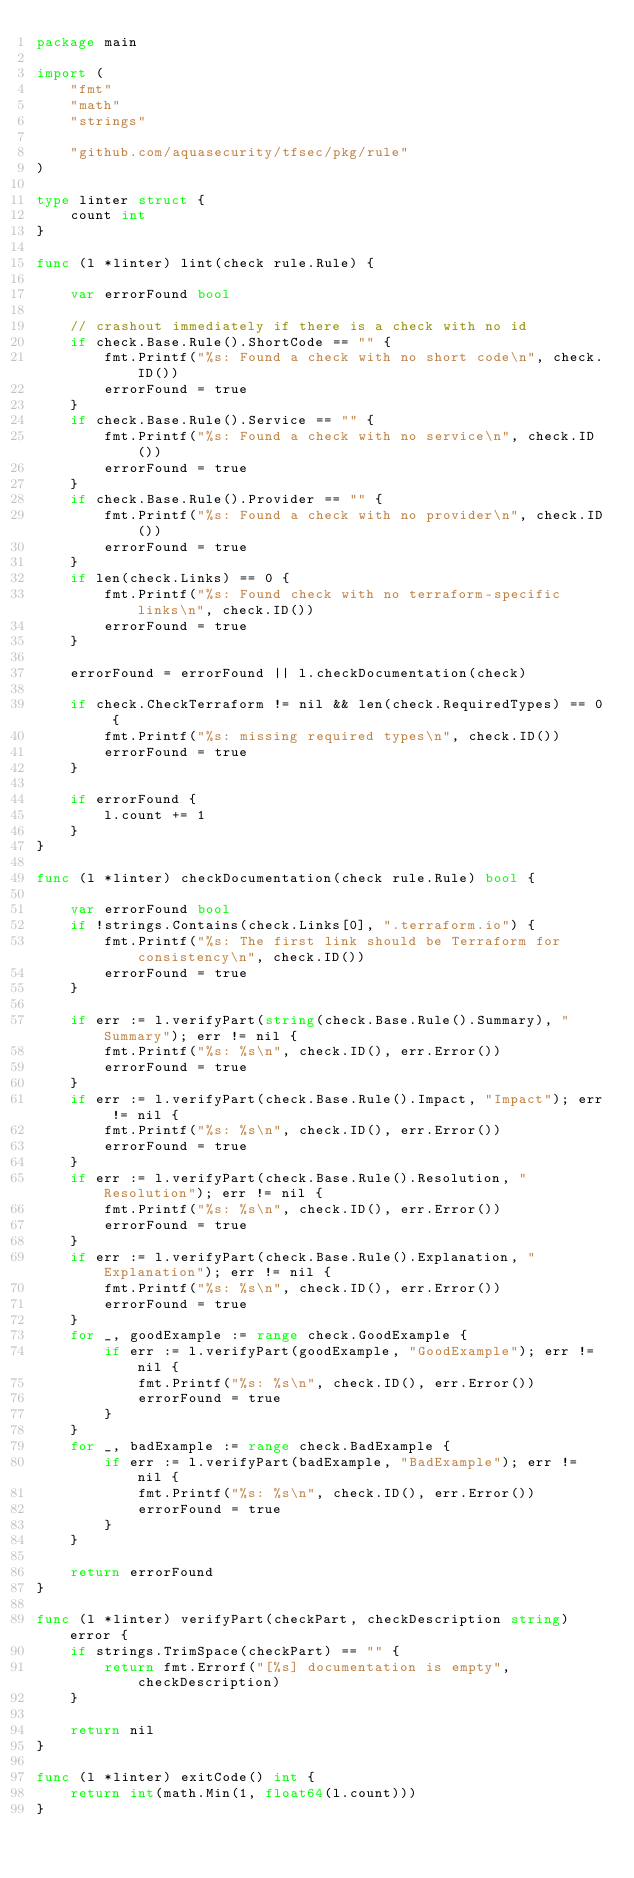<code> <loc_0><loc_0><loc_500><loc_500><_Go_>package main

import (
	"fmt"
	"math"
	"strings"

	"github.com/aquasecurity/tfsec/pkg/rule"
)

type linter struct {
	count int
}

func (l *linter) lint(check rule.Rule) {

	var errorFound bool

	// crashout immediately if there is a check with no id
	if check.Base.Rule().ShortCode == "" {
		fmt.Printf("%s: Found a check with no short code\n", check.ID())
		errorFound = true
	}
	if check.Base.Rule().Service == "" {
		fmt.Printf("%s: Found a check with no service\n", check.ID())
		errorFound = true
	}
	if check.Base.Rule().Provider == "" {
		fmt.Printf("%s: Found a check with no provider\n", check.ID())
		errorFound = true
	}
	if len(check.Links) == 0 {
		fmt.Printf("%s: Found check with no terraform-specific links\n", check.ID())
		errorFound = true
	}

	errorFound = errorFound || l.checkDocumentation(check)

	if check.CheckTerraform != nil && len(check.RequiredTypes) == 0 {
		fmt.Printf("%s: missing required types\n", check.ID())
		errorFound = true
	}

	if errorFound {
		l.count += 1
	}
}

func (l *linter) checkDocumentation(check rule.Rule) bool {

	var errorFound bool
	if !strings.Contains(check.Links[0], ".terraform.io") {
		fmt.Printf("%s: The first link should be Terraform for consistency\n", check.ID())
		errorFound = true
	}

	if err := l.verifyPart(string(check.Base.Rule().Summary), "Summary"); err != nil {
		fmt.Printf("%s: %s\n", check.ID(), err.Error())
		errorFound = true
	}
	if err := l.verifyPart(check.Base.Rule().Impact, "Impact"); err != nil {
		fmt.Printf("%s: %s\n", check.ID(), err.Error())
		errorFound = true
	}
	if err := l.verifyPart(check.Base.Rule().Resolution, "Resolution"); err != nil {
		fmt.Printf("%s: %s\n", check.ID(), err.Error())
		errorFound = true
	}
	if err := l.verifyPart(check.Base.Rule().Explanation, "Explanation"); err != nil {
		fmt.Printf("%s: %s\n", check.ID(), err.Error())
		errorFound = true
	}
	for _, goodExample := range check.GoodExample {
		if err := l.verifyPart(goodExample, "GoodExample"); err != nil {
			fmt.Printf("%s: %s\n", check.ID(), err.Error())
			errorFound = true
		}
	}
	for _, badExample := range check.BadExample {
		if err := l.verifyPart(badExample, "BadExample"); err != nil {
			fmt.Printf("%s: %s\n", check.ID(), err.Error())
			errorFound = true
		}
	}

	return errorFound
}

func (l *linter) verifyPart(checkPart, checkDescription string) error {
	if strings.TrimSpace(checkPart) == "" {
		return fmt.Errorf("[%s] documentation is empty", checkDescription)
	}

	return nil
}

func (l *linter) exitCode() int {
	return int(math.Min(1, float64(l.count)))
}
</code> 